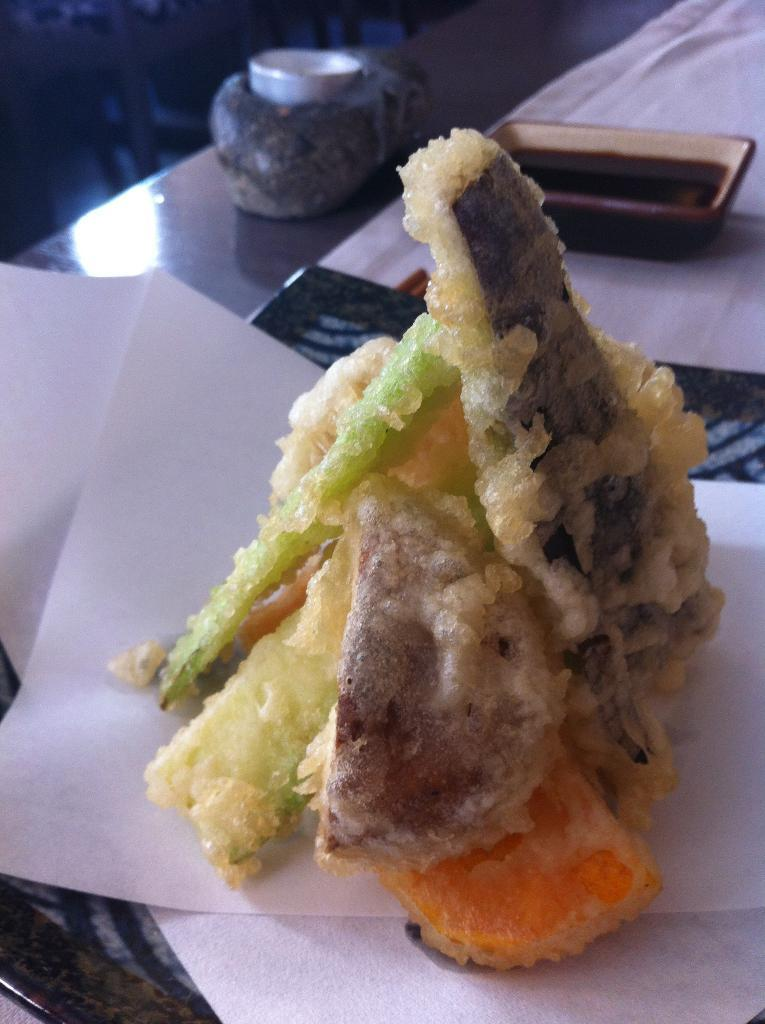What is on the plate in the image? There is a food item on a plate in the image. What condiment is present in the image? There is a bowl of ketchup in the image. What type of object is on the table in the image? There is a paper and a cloth on the table in the image. Can you see any grass growing on the table in the image? No, there is no grass present in the image. Is there an achiever being recognized in the image? There is no indication of an achiever or any recognition in the image. 